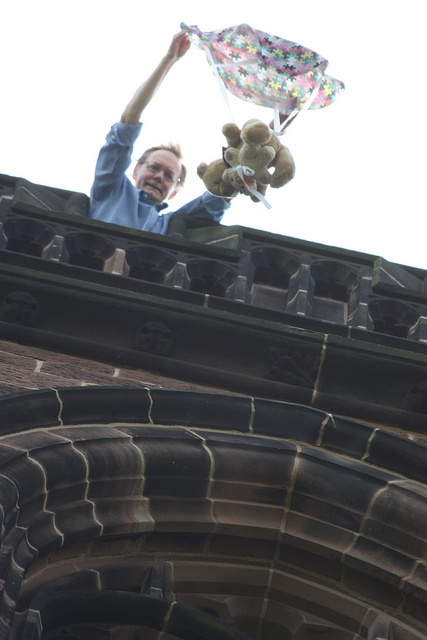Describe the objects in this image and their specific colors. I can see people in white, gray, and darkgray tones, kite in white, lightgray, darkgray, lightblue, and lightpink tones, teddy bear in white, gray, and darkgray tones, and teddy bear in white, gray, darkgray, and lightgray tones in this image. 